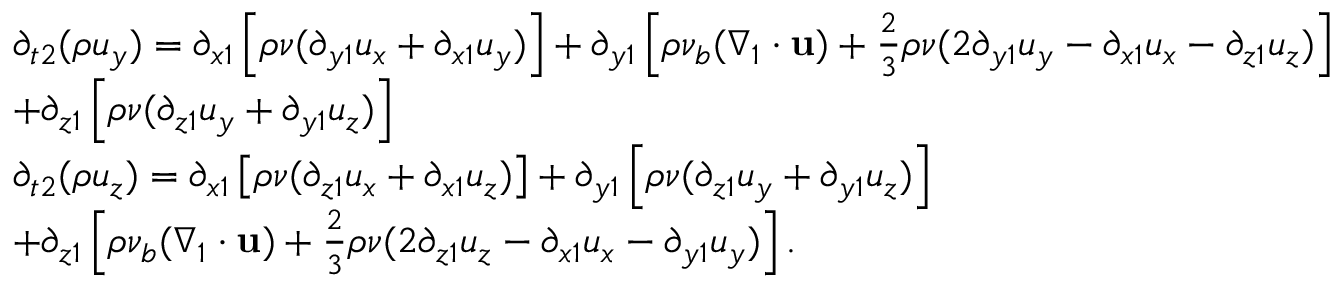Convert formula to latex. <formula><loc_0><loc_0><loc_500><loc_500>\begin{array} { l } { { \partial _ { t 2 } } ( \rho { u _ { y } } ) = { \partial _ { x 1 } } \left [ { \rho \nu ( { \partial _ { y 1 } } { u _ { x } } + { \partial _ { x 1 } } { u _ { y } } ) } \right ] + { \partial _ { y 1 } } \left [ { \rho { \nu _ { b } } ( { \nabla _ { 1 } } \cdot { u } ) + \frac { 2 } { 3 } \rho \nu ( 2 { \partial _ { y 1 } } { u _ { y } } - { \partial _ { x 1 } } { u _ { x } } - { \partial _ { z 1 } } { u _ { z } } ) } \right ] } \\ { + { \partial _ { z 1 } } \left [ { \rho \nu ( { \partial _ { z 1 } } { u _ { y } } + { \partial _ { y 1 } } { u _ { z } } ) } \right ] } \\ { { \partial _ { t 2 } } ( \rho { u _ { z } } ) = { \partial _ { x 1 } } \left [ { \rho \nu ( { \partial _ { z 1 } } { u _ { x } } + { \partial _ { x 1 } } { u _ { z } } ) } \right ] + { \partial _ { y 1 } } \left [ { \rho \nu ( { \partial _ { z 1 } } { u _ { y } } + { \partial _ { y 1 } } { u _ { z } } ) } \right ] } \\ { + { \partial _ { z 1 } } \left [ { \rho { \nu _ { b } } ( { \nabla _ { 1 } } \cdot { u } ) + \frac { 2 } { 3 } \rho \nu ( 2 { \partial _ { z 1 } } { u _ { z } } - { \partial _ { x 1 } } { u _ { x } } - { \partial _ { y 1 } } { u _ { y } } ) } \right ] . } \end{array}</formula> 